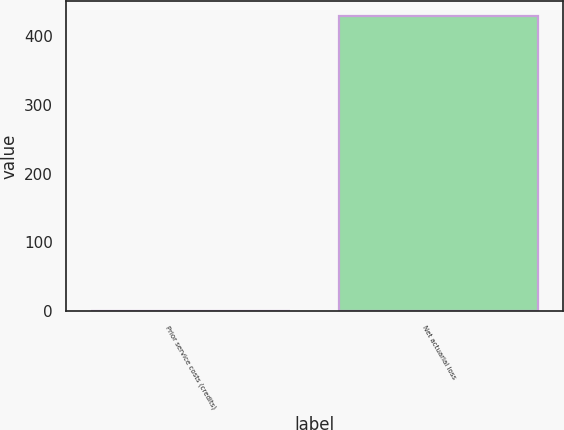Convert chart to OTSL. <chart><loc_0><loc_0><loc_500><loc_500><bar_chart><fcel>Prior service costs (credits)<fcel>Net actuarial loss<nl><fcel>1<fcel>429<nl></chart> 